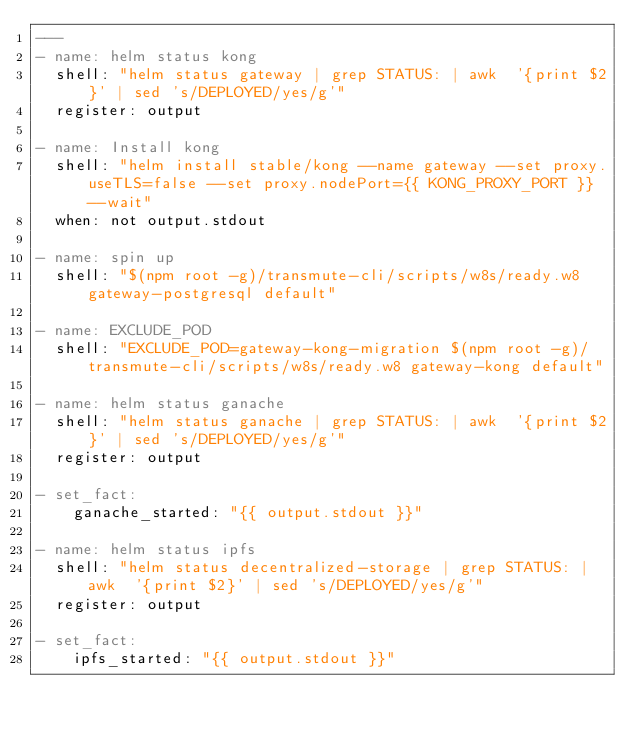<code> <loc_0><loc_0><loc_500><loc_500><_YAML_>---
- name: helm status kong
  shell: "helm status gateway | grep STATUS: | awk  '{print $2}' | sed 's/DEPLOYED/yes/g'"
  register: output

- name: Install kong
  shell: "helm install stable/kong --name gateway --set proxy.useTLS=false --set proxy.nodePort={{ KONG_PROXY_PORT }} --wait"
  when: not output.stdout

- name: spin up
  shell: "$(npm root -g)/transmute-cli/scripts/w8s/ready.w8 gateway-postgresql default"

- name: EXCLUDE_POD
  shell: "EXCLUDE_POD=gateway-kong-migration $(npm root -g)/transmute-cli/scripts/w8s/ready.w8 gateway-kong default"

- name: helm status ganache
  shell: "helm status ganache | grep STATUS: | awk  '{print $2}' | sed 's/DEPLOYED/yes/g'"
  register: output

- set_fact:
    ganache_started: "{{ output.stdout }}"

- name: helm status ipfs
  shell: "helm status decentralized-storage | grep STATUS: | awk  '{print $2}' | sed 's/DEPLOYED/yes/g'"
  register: output

- set_fact:
    ipfs_started: "{{ output.stdout }}"
</code> 